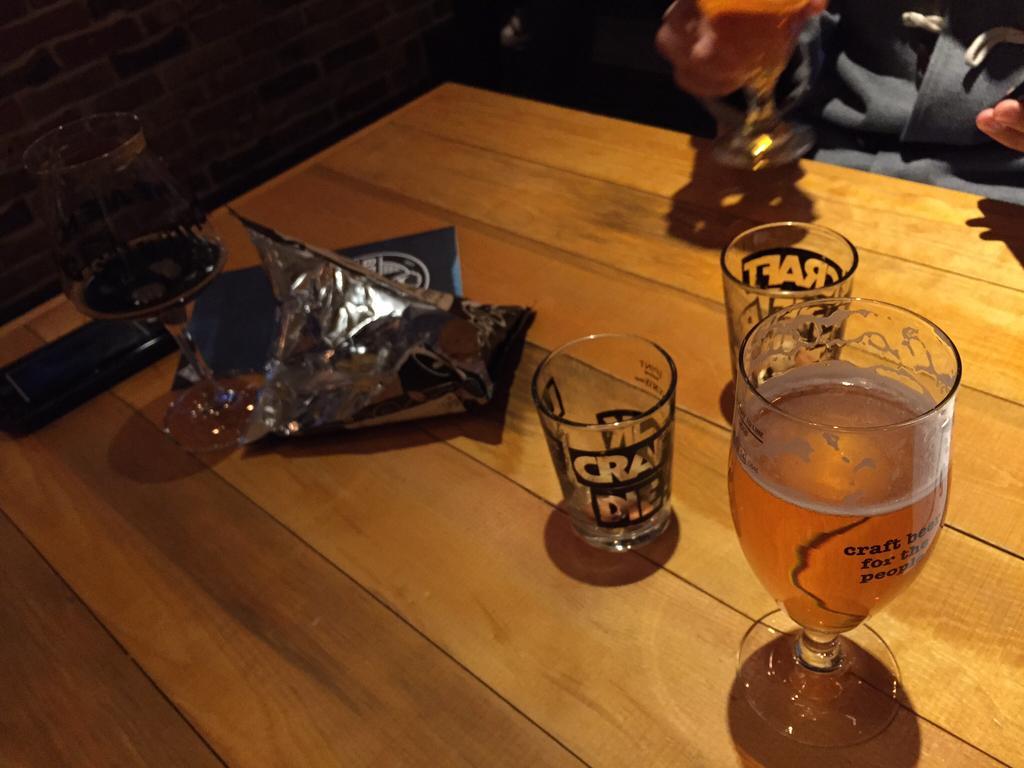Could you give a brief overview of what you see in this image? There is a table which has a glass of wine and a empty glasses on it and there is a person in the right top corner. 